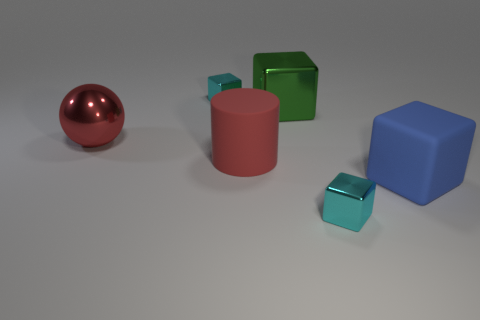Are there fewer big red things that are behind the red metallic object than objects? Based on the image, yes, there are fewer objects positioned behind the large red metallic sphere compared to the total number of objects present. Specifically, there appears to be only one large red cylinder behind the red sphere, whereas the image includes several distinct objects of various colors and shapes. 